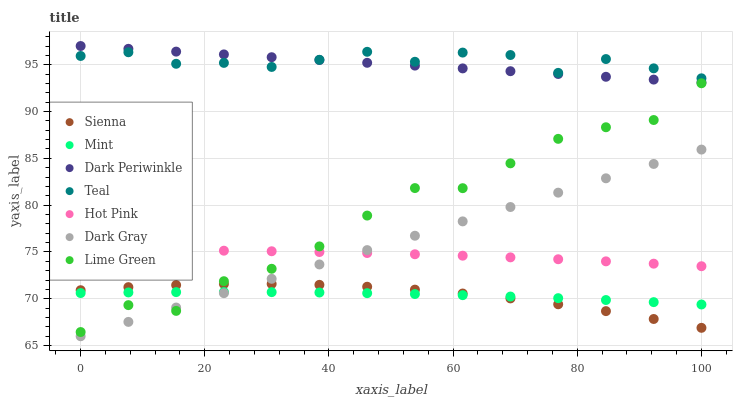Does Mint have the minimum area under the curve?
Answer yes or no. Yes. Does Teal have the maximum area under the curve?
Answer yes or no. Yes. Does Lime Green have the minimum area under the curve?
Answer yes or no. No. Does Lime Green have the maximum area under the curve?
Answer yes or no. No. Is Dark Periwinkle the smoothest?
Answer yes or no. Yes. Is Lime Green the roughest?
Answer yes or no. Yes. Is Hot Pink the smoothest?
Answer yes or no. No. Is Hot Pink the roughest?
Answer yes or no. No. Does Dark Gray have the lowest value?
Answer yes or no. Yes. Does Lime Green have the lowest value?
Answer yes or no. No. Does Dark Periwinkle have the highest value?
Answer yes or no. Yes. Does Lime Green have the highest value?
Answer yes or no. No. Is Mint less than Teal?
Answer yes or no. Yes. Is Teal greater than Lime Green?
Answer yes or no. Yes. Does Lime Green intersect Mint?
Answer yes or no. Yes. Is Lime Green less than Mint?
Answer yes or no. No. Is Lime Green greater than Mint?
Answer yes or no. No. Does Mint intersect Teal?
Answer yes or no. No. 